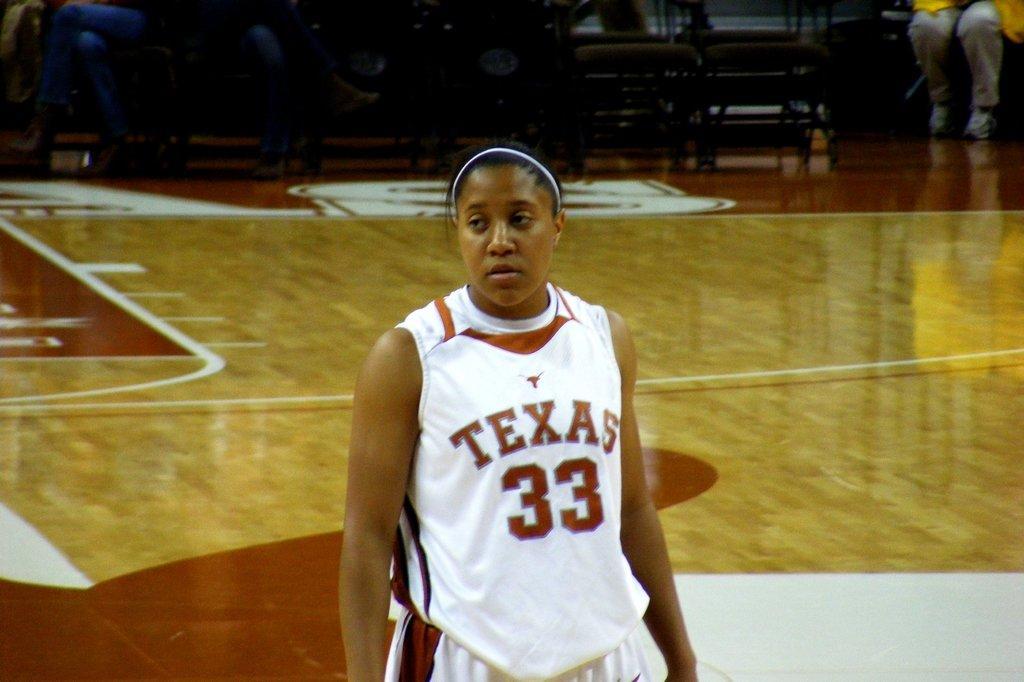Please provide a concise description of this image. In this image I can see a woman in the front and I can see she is wearing the white colour dress. I can also see something is written on her dress. In the background I can see few people are sitting on chairs and I can also see few empty chairs. 